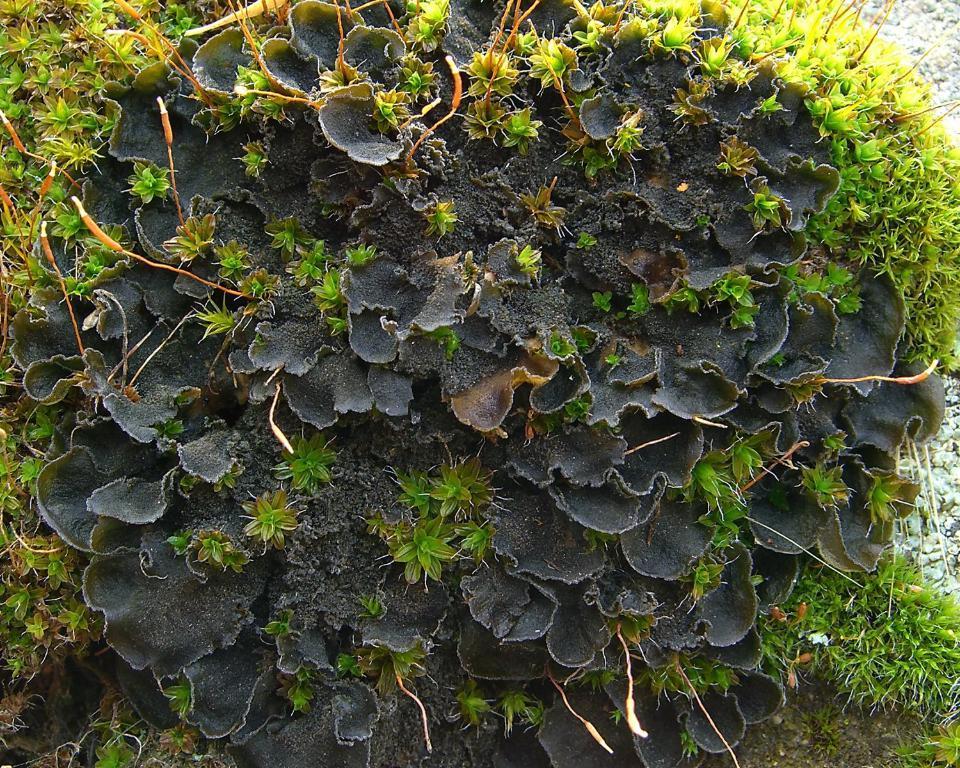Can you describe this image briefly? In the center of the image there is a plant. At the bottom we can see grass. 